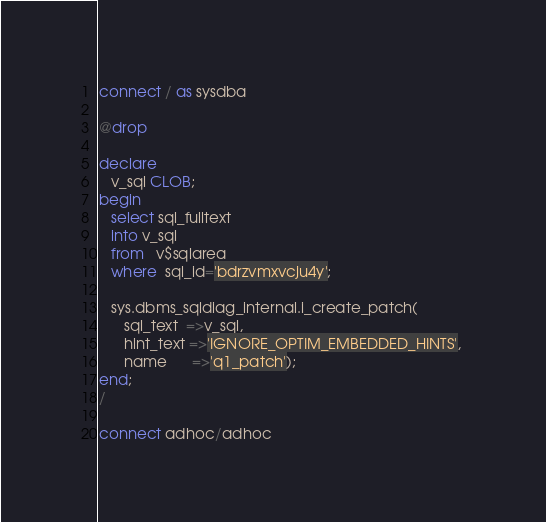Convert code to text. <code><loc_0><loc_0><loc_500><loc_500><_SQL_>connect / as sysdba

@drop

declare
   v_sql CLOB;
begin
   select sql_fulltext 
   into v_sql 
   from   v$sqlarea 
   where  sql_id='bdrzvmxvcju4y';

   sys.dbms_sqldiag_internal.i_create_patch(
      sql_text  =>v_sql,
      hint_text =>'IGNORE_OPTIM_EMBEDDED_HINTS', 
      name      =>'q1_patch');
end;
/

connect adhoc/adhoc
</code> 